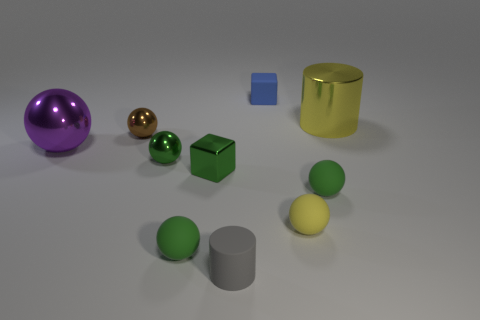Subtract all gray cylinders. How many green balls are left? 3 Subtract 1 balls. How many balls are left? 5 Subtract all yellow balls. How many balls are left? 5 Subtract all brown spheres. How many spheres are left? 5 Subtract all purple spheres. Subtract all yellow cylinders. How many spheres are left? 5 Subtract all cubes. How many objects are left? 8 Add 5 big gray metallic balls. How many big gray metallic balls exist? 5 Subtract 0 red cubes. How many objects are left? 10 Subtract all small yellow rubber objects. Subtract all blue rubber cubes. How many objects are left? 8 Add 1 brown metallic things. How many brown metallic things are left? 2 